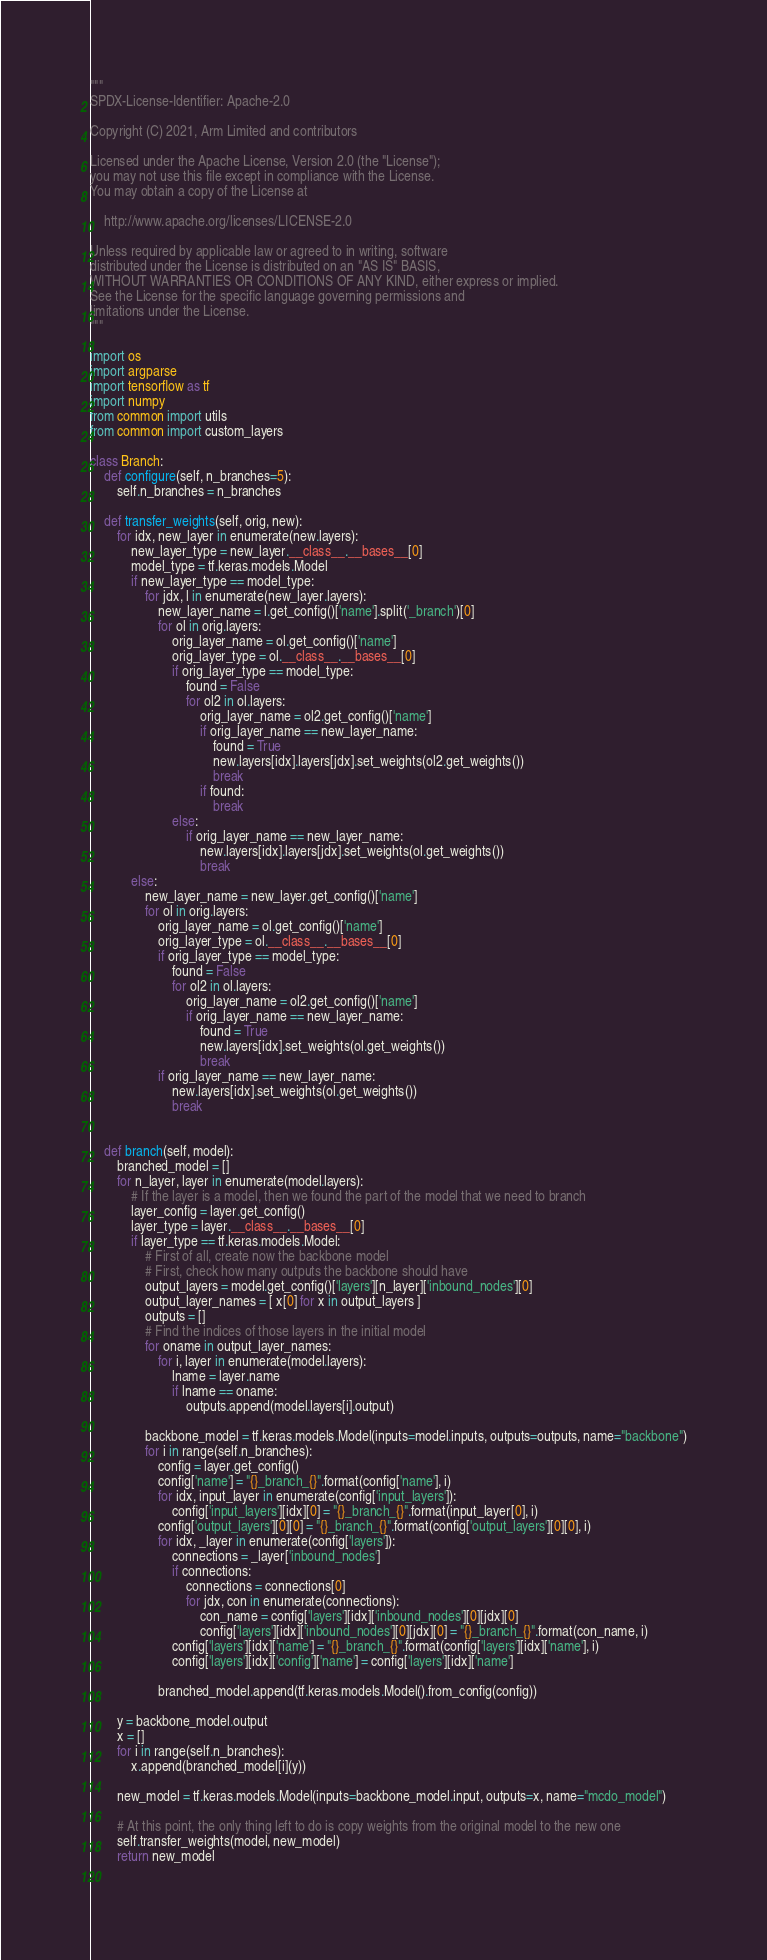<code> <loc_0><loc_0><loc_500><loc_500><_Python_>"""
SPDX-License-Identifier: Apache-2.0

Copyright (C) 2021, Arm Limited and contributors

Licensed under the Apache License, Version 2.0 (the "License");
you may not use this file except in compliance with the License.
You may obtain a copy of the License at

    http://www.apache.org/licenses/LICENSE-2.0

Unless required by applicable law or agreed to in writing, software
distributed under the License is distributed on an "AS IS" BASIS,
WITHOUT WARRANTIES OR CONDITIONS OF ANY KIND, either express or implied.
See the License for the specific language governing permissions and
limitations under the License.
"""

import os
import argparse
import tensorflow as tf
import numpy
from common import utils
from common import custom_layers

class Branch:
    def configure(self, n_branches=5):
        self.n_branches = n_branches

    def transfer_weights(self, orig, new):
        for idx, new_layer in enumerate(new.layers):
            new_layer_type = new_layer.__class__.__bases__[0]
            model_type = tf.keras.models.Model
            if new_layer_type == model_type:
                for jdx, l in enumerate(new_layer.layers):
                    new_layer_name = l.get_config()['name'].split('_branch')[0]
                    for ol in orig.layers:
                        orig_layer_name = ol.get_config()['name']
                        orig_layer_type = ol.__class__.__bases__[0]
                        if orig_layer_type == model_type:
                            found = False
                            for ol2 in ol.layers:
                                orig_layer_name = ol2.get_config()['name']
                                if orig_layer_name == new_layer_name:
                                    found = True
                                    new.layers[idx].layers[jdx].set_weights(ol2.get_weights())
                                    break
                                if found:
                                    break
                        else:
                            if orig_layer_name == new_layer_name:
                                new.layers[idx].layers[jdx].set_weights(ol.get_weights())
                                break
            else:
                new_layer_name = new_layer.get_config()['name']
                for ol in orig.layers:
                    orig_layer_name = ol.get_config()['name']
                    orig_layer_type = ol.__class__.__bases__[0]
                    if orig_layer_type == model_type:
                        found = False
                        for ol2 in ol.layers:
                            orig_layer_name = ol2.get_config()['name']
                            if orig_layer_name == new_layer_name:
                                found = True
                                new.layers[idx].set_weights(ol.get_weights())
                                break
                    if orig_layer_name == new_layer_name:
                        new.layers[idx].set_weights(ol.get_weights())
                        break


    def branch(self, model):
        branched_model = []
        for n_layer, layer in enumerate(model.layers):
            # If the layer is a model, then we found the part of the model that we need to branch
            layer_config = layer.get_config()
            layer_type = layer.__class__.__bases__[0]
            if layer_type == tf.keras.models.Model:
                # First of all, create now the backbone model
                # First, check how many outputs the backbone should have
                output_layers = model.get_config()['layers'][n_layer]['inbound_nodes'][0]
                output_layer_names = [ x[0] for x in output_layers ]
                outputs = []
                # Find the indices of those layers in the initial model
                for oname in output_layer_names:
                    for i, layer in enumerate(model.layers):
                        lname = layer.name
                        if lname == oname:
                            outputs.append(model.layers[i].output)

                backbone_model = tf.keras.models.Model(inputs=model.inputs, outputs=outputs, name="backbone")
                for i in range(self.n_branches):
                    config = layer.get_config()
                    config['name'] = "{}_branch_{}".format(config['name'], i)
                    for idx, input_layer in enumerate(config['input_layers']):
                        config['input_layers'][idx][0] = "{}_branch_{}".format(input_layer[0], i)
                    config['output_layers'][0][0] = "{}_branch_{}".format(config['output_layers'][0][0], i)
                    for idx, _layer in enumerate(config['layers']):
                        connections = _layer['inbound_nodes']
                        if connections:
                            connections = connections[0]
                            for jdx, con in enumerate(connections):
                                con_name = config['layers'][idx]['inbound_nodes'][0][jdx][0]
                                config['layers'][idx]['inbound_nodes'][0][jdx][0] = "{}_branch_{}".format(con_name, i)
                        config['layers'][idx]['name'] = "{}_branch_{}".format(config['layers'][idx]['name'], i)
                        config['layers'][idx]['config']['name'] = config['layers'][idx]['name']

                    branched_model.append(tf.keras.models.Model().from_config(config))

        y = backbone_model.output
        x = []
        for i in range(self.n_branches):
            x.append(branched_model[i](y))

        new_model = tf.keras.models.Model(inputs=backbone_model.input, outputs=x, name="mcdo_model")
        
        # At this point, the only thing left to do is copy weights from the original model to the new one
        self.transfer_weights(model, new_model)
        return new_model
    
</code> 